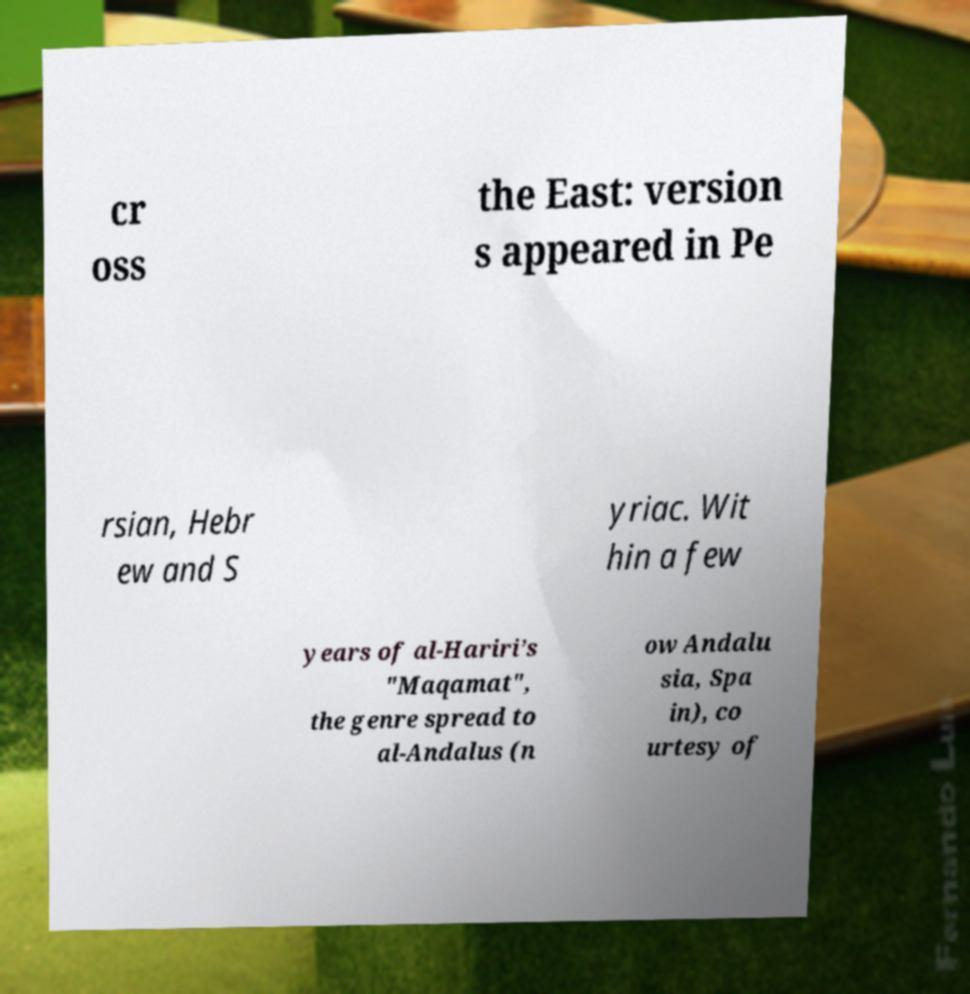Could you assist in decoding the text presented in this image and type it out clearly? cr oss the East: version s appeared in Pe rsian, Hebr ew and S yriac. Wit hin a few years of al-Hariri’s "Maqamat", the genre spread to al-Andalus (n ow Andalu sia, Spa in), co urtesy of 